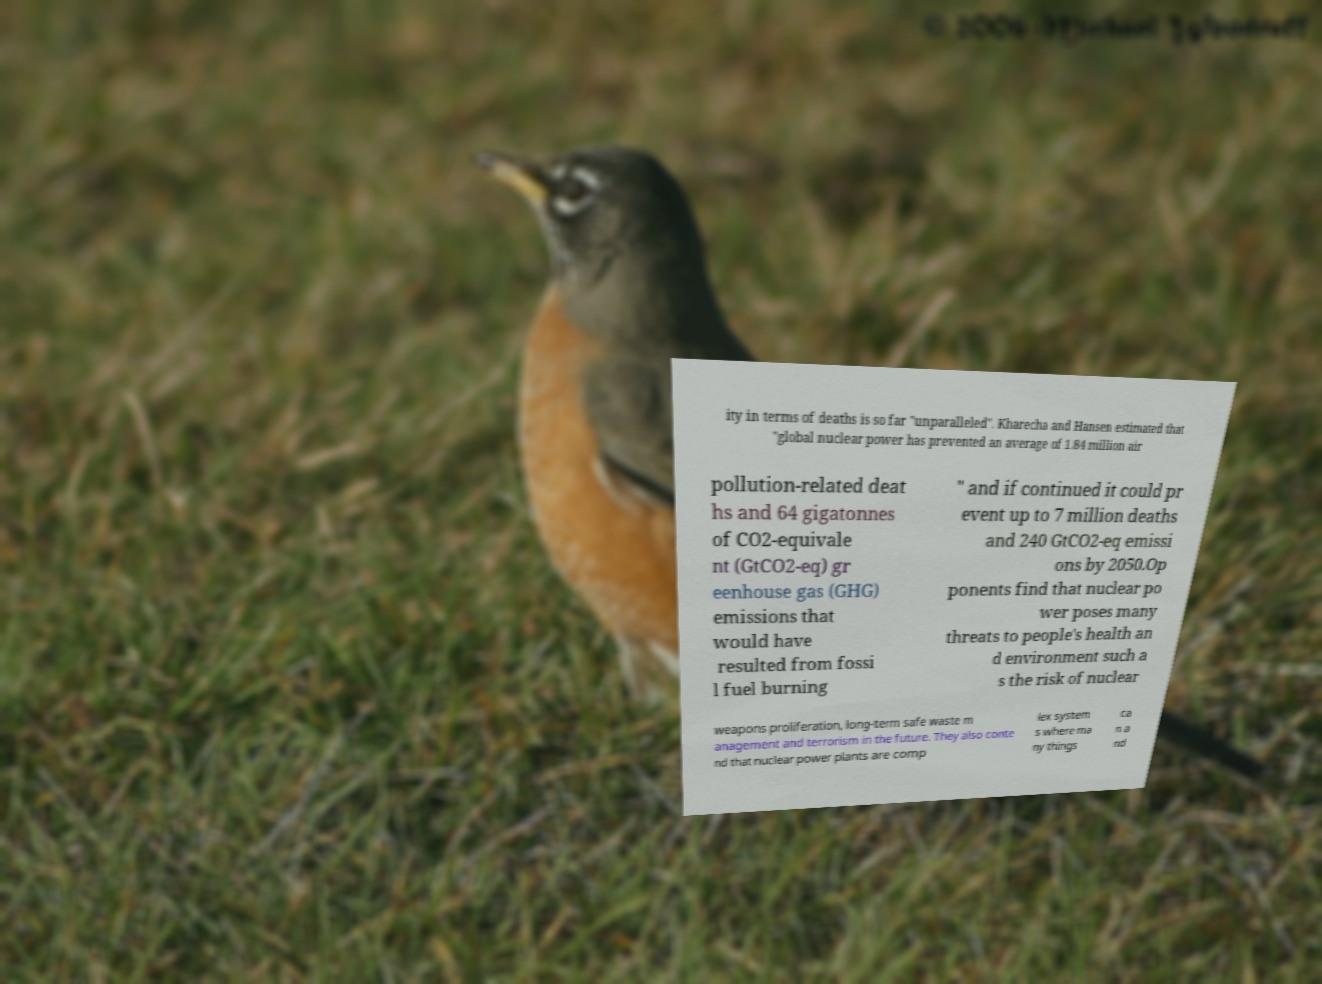Could you assist in decoding the text presented in this image and type it out clearly? ity in terms of deaths is so far "unparalleled". Kharecha and Hansen estimated that "global nuclear power has prevented an average of 1.84 million air pollution-related deat hs and 64 gigatonnes of CO2-equivale nt (GtCO2-eq) gr eenhouse gas (GHG) emissions that would have resulted from fossi l fuel burning " and if continued it could pr event up to 7 million deaths and 240 GtCO2-eq emissi ons by 2050.Op ponents find that nuclear po wer poses many threats to people's health an d environment such a s the risk of nuclear weapons proliferation, long-term safe waste m anagement and terrorism in the future. They also conte nd that nuclear power plants are comp lex system s where ma ny things ca n a nd 